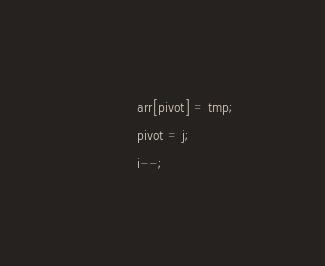<code> <loc_0><loc_0><loc_500><loc_500><_C_>			arr[pivot] = tmp;
			pivot = j;
			i--;</code> 